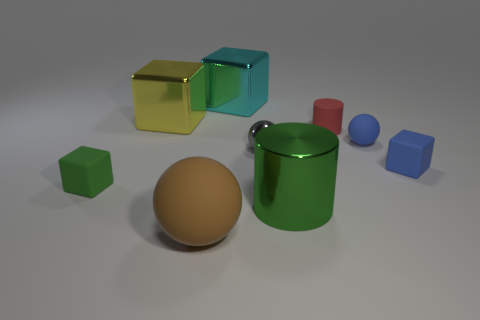The big object that is in front of the blue matte cube and behind the brown sphere has what shape?
Make the answer very short. Cylinder. What is the material of the cyan block?
Make the answer very short. Metal. How many cubes are purple objects or large brown matte things?
Provide a succinct answer. 0. Does the large brown object have the same material as the tiny blue cube?
Your response must be concise. Yes. What is the size of the blue rubber thing that is the same shape as the tiny gray thing?
Provide a succinct answer. Small. What is the material of the large object that is both right of the large yellow shiny object and behind the big green metal cylinder?
Give a very brief answer. Metal. Are there the same number of tiny metal balls in front of the tiny gray metallic ball and tiny red cylinders?
Offer a very short reply. No. How many objects are rubber blocks that are on the right side of the big brown sphere or small blue rubber blocks?
Offer a terse response. 1. There is a rubber cube to the right of the tiny green cube; does it have the same color as the tiny matte ball?
Keep it short and to the point. Yes. What size is the rubber cube that is to the right of the large cyan block?
Provide a short and direct response. Small. 